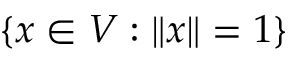<formula> <loc_0><loc_0><loc_500><loc_500>\{ x \in V \colon \| x \| = 1 \}</formula> 